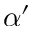<formula> <loc_0><loc_0><loc_500><loc_500>\alpha ^ { \prime }</formula> 